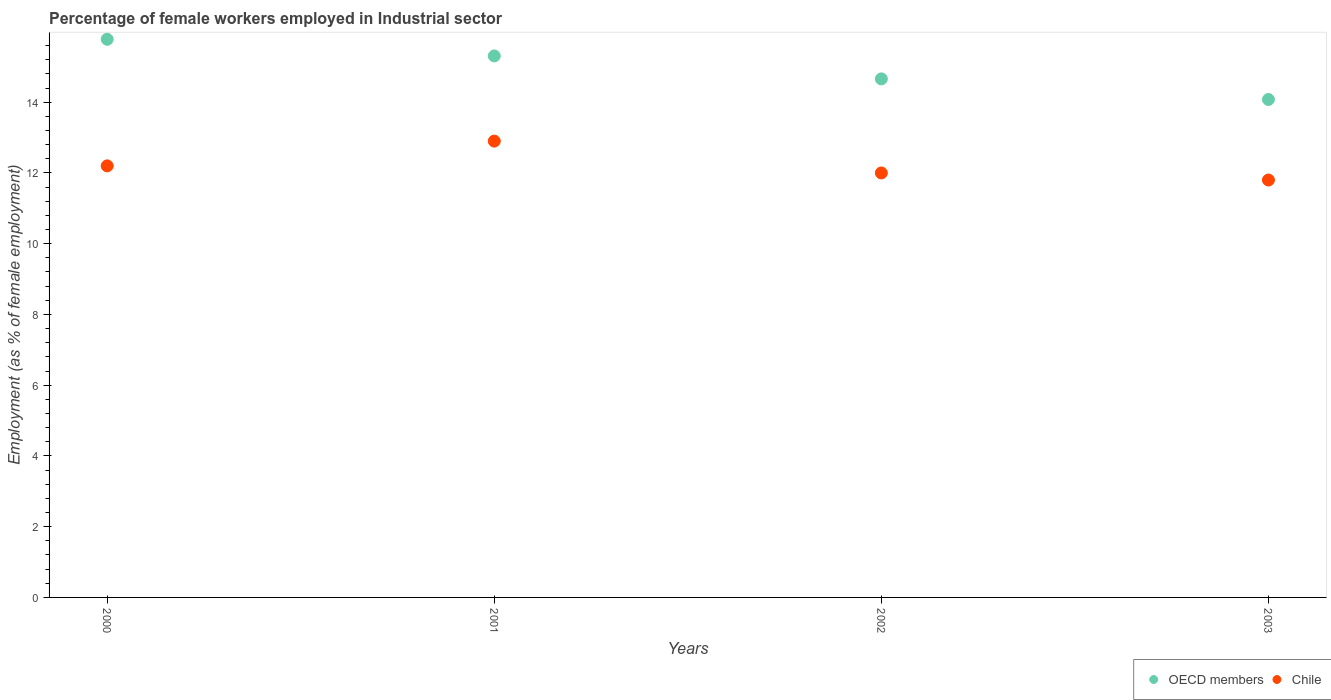How many different coloured dotlines are there?
Your answer should be compact. 2. Is the number of dotlines equal to the number of legend labels?
Offer a very short reply. Yes. What is the percentage of females employed in Industrial sector in Chile in 2001?
Offer a terse response. 12.9. Across all years, what is the maximum percentage of females employed in Industrial sector in OECD members?
Make the answer very short. 15.78. Across all years, what is the minimum percentage of females employed in Industrial sector in OECD members?
Your response must be concise. 14.08. What is the total percentage of females employed in Industrial sector in OECD members in the graph?
Make the answer very short. 59.82. What is the difference between the percentage of females employed in Industrial sector in Chile in 2001 and that in 2002?
Give a very brief answer. 0.9. What is the difference between the percentage of females employed in Industrial sector in OECD members in 2002 and the percentage of females employed in Industrial sector in Chile in 2003?
Provide a succinct answer. 2.86. What is the average percentage of females employed in Industrial sector in Chile per year?
Provide a succinct answer. 12.22. In the year 2002, what is the difference between the percentage of females employed in Industrial sector in Chile and percentage of females employed in Industrial sector in OECD members?
Offer a very short reply. -2.66. In how many years, is the percentage of females employed in Industrial sector in OECD members greater than 10 %?
Your response must be concise. 4. What is the ratio of the percentage of females employed in Industrial sector in Chile in 2001 to that in 2003?
Your answer should be very brief. 1.09. Is the percentage of females employed in Industrial sector in Chile in 2002 less than that in 2003?
Ensure brevity in your answer.  No. What is the difference between the highest and the second highest percentage of females employed in Industrial sector in Chile?
Your answer should be very brief. 0.7. What is the difference between the highest and the lowest percentage of females employed in Industrial sector in OECD members?
Provide a succinct answer. 1.7. In how many years, is the percentage of females employed in Industrial sector in Chile greater than the average percentage of females employed in Industrial sector in Chile taken over all years?
Provide a succinct answer. 1. Is the percentage of females employed in Industrial sector in OECD members strictly less than the percentage of females employed in Industrial sector in Chile over the years?
Ensure brevity in your answer.  No. How many dotlines are there?
Your answer should be very brief. 2. How many years are there in the graph?
Provide a short and direct response. 4. What is the difference between two consecutive major ticks on the Y-axis?
Offer a terse response. 2. Does the graph contain any zero values?
Keep it short and to the point. No. What is the title of the graph?
Keep it short and to the point. Percentage of female workers employed in Industrial sector. Does "Brunei Darussalam" appear as one of the legend labels in the graph?
Make the answer very short. No. What is the label or title of the Y-axis?
Provide a short and direct response. Employment (as % of female employment). What is the Employment (as % of female employment) in OECD members in 2000?
Ensure brevity in your answer.  15.78. What is the Employment (as % of female employment) in Chile in 2000?
Offer a very short reply. 12.2. What is the Employment (as % of female employment) of OECD members in 2001?
Keep it short and to the point. 15.31. What is the Employment (as % of female employment) of Chile in 2001?
Give a very brief answer. 12.9. What is the Employment (as % of female employment) in OECD members in 2002?
Your answer should be very brief. 14.66. What is the Employment (as % of female employment) in OECD members in 2003?
Make the answer very short. 14.08. What is the Employment (as % of female employment) in Chile in 2003?
Offer a terse response. 11.8. Across all years, what is the maximum Employment (as % of female employment) of OECD members?
Your response must be concise. 15.78. Across all years, what is the maximum Employment (as % of female employment) in Chile?
Offer a very short reply. 12.9. Across all years, what is the minimum Employment (as % of female employment) of OECD members?
Offer a terse response. 14.08. Across all years, what is the minimum Employment (as % of female employment) in Chile?
Keep it short and to the point. 11.8. What is the total Employment (as % of female employment) of OECD members in the graph?
Make the answer very short. 59.82. What is the total Employment (as % of female employment) of Chile in the graph?
Offer a very short reply. 48.9. What is the difference between the Employment (as % of female employment) in OECD members in 2000 and that in 2001?
Provide a succinct answer. 0.47. What is the difference between the Employment (as % of female employment) of OECD members in 2000 and that in 2002?
Give a very brief answer. 1.12. What is the difference between the Employment (as % of female employment) in Chile in 2000 and that in 2002?
Provide a short and direct response. 0.2. What is the difference between the Employment (as % of female employment) in OECD members in 2000 and that in 2003?
Give a very brief answer. 1.7. What is the difference between the Employment (as % of female employment) in Chile in 2000 and that in 2003?
Give a very brief answer. 0.4. What is the difference between the Employment (as % of female employment) in OECD members in 2001 and that in 2002?
Provide a short and direct response. 0.65. What is the difference between the Employment (as % of female employment) in Chile in 2001 and that in 2002?
Make the answer very short. 0.9. What is the difference between the Employment (as % of female employment) of OECD members in 2001 and that in 2003?
Ensure brevity in your answer.  1.23. What is the difference between the Employment (as % of female employment) in OECD members in 2002 and that in 2003?
Provide a succinct answer. 0.58. What is the difference between the Employment (as % of female employment) of OECD members in 2000 and the Employment (as % of female employment) of Chile in 2001?
Make the answer very short. 2.88. What is the difference between the Employment (as % of female employment) in OECD members in 2000 and the Employment (as % of female employment) in Chile in 2002?
Provide a succinct answer. 3.78. What is the difference between the Employment (as % of female employment) in OECD members in 2000 and the Employment (as % of female employment) in Chile in 2003?
Offer a terse response. 3.98. What is the difference between the Employment (as % of female employment) of OECD members in 2001 and the Employment (as % of female employment) of Chile in 2002?
Ensure brevity in your answer.  3.31. What is the difference between the Employment (as % of female employment) of OECD members in 2001 and the Employment (as % of female employment) of Chile in 2003?
Keep it short and to the point. 3.51. What is the difference between the Employment (as % of female employment) of OECD members in 2002 and the Employment (as % of female employment) of Chile in 2003?
Ensure brevity in your answer.  2.86. What is the average Employment (as % of female employment) in OECD members per year?
Provide a succinct answer. 14.96. What is the average Employment (as % of female employment) of Chile per year?
Offer a terse response. 12.22. In the year 2000, what is the difference between the Employment (as % of female employment) in OECD members and Employment (as % of female employment) in Chile?
Your answer should be very brief. 3.58. In the year 2001, what is the difference between the Employment (as % of female employment) in OECD members and Employment (as % of female employment) in Chile?
Offer a terse response. 2.41. In the year 2002, what is the difference between the Employment (as % of female employment) in OECD members and Employment (as % of female employment) in Chile?
Provide a short and direct response. 2.66. In the year 2003, what is the difference between the Employment (as % of female employment) of OECD members and Employment (as % of female employment) of Chile?
Your response must be concise. 2.28. What is the ratio of the Employment (as % of female employment) of OECD members in 2000 to that in 2001?
Offer a terse response. 1.03. What is the ratio of the Employment (as % of female employment) of Chile in 2000 to that in 2001?
Keep it short and to the point. 0.95. What is the ratio of the Employment (as % of female employment) in OECD members in 2000 to that in 2002?
Keep it short and to the point. 1.08. What is the ratio of the Employment (as % of female employment) in Chile in 2000 to that in 2002?
Keep it short and to the point. 1.02. What is the ratio of the Employment (as % of female employment) in OECD members in 2000 to that in 2003?
Offer a very short reply. 1.12. What is the ratio of the Employment (as % of female employment) of Chile in 2000 to that in 2003?
Offer a terse response. 1.03. What is the ratio of the Employment (as % of female employment) of OECD members in 2001 to that in 2002?
Offer a very short reply. 1.04. What is the ratio of the Employment (as % of female employment) in Chile in 2001 to that in 2002?
Offer a very short reply. 1.07. What is the ratio of the Employment (as % of female employment) of OECD members in 2001 to that in 2003?
Provide a succinct answer. 1.09. What is the ratio of the Employment (as % of female employment) of Chile in 2001 to that in 2003?
Your answer should be very brief. 1.09. What is the ratio of the Employment (as % of female employment) of OECD members in 2002 to that in 2003?
Your answer should be very brief. 1.04. What is the ratio of the Employment (as % of female employment) of Chile in 2002 to that in 2003?
Offer a terse response. 1.02. What is the difference between the highest and the second highest Employment (as % of female employment) of OECD members?
Offer a very short reply. 0.47. What is the difference between the highest and the second highest Employment (as % of female employment) in Chile?
Make the answer very short. 0.7. What is the difference between the highest and the lowest Employment (as % of female employment) of OECD members?
Provide a succinct answer. 1.7. 